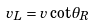<formula> <loc_0><loc_0><loc_500><loc_500>v _ { L } = v \cot \theta _ { R }</formula> 